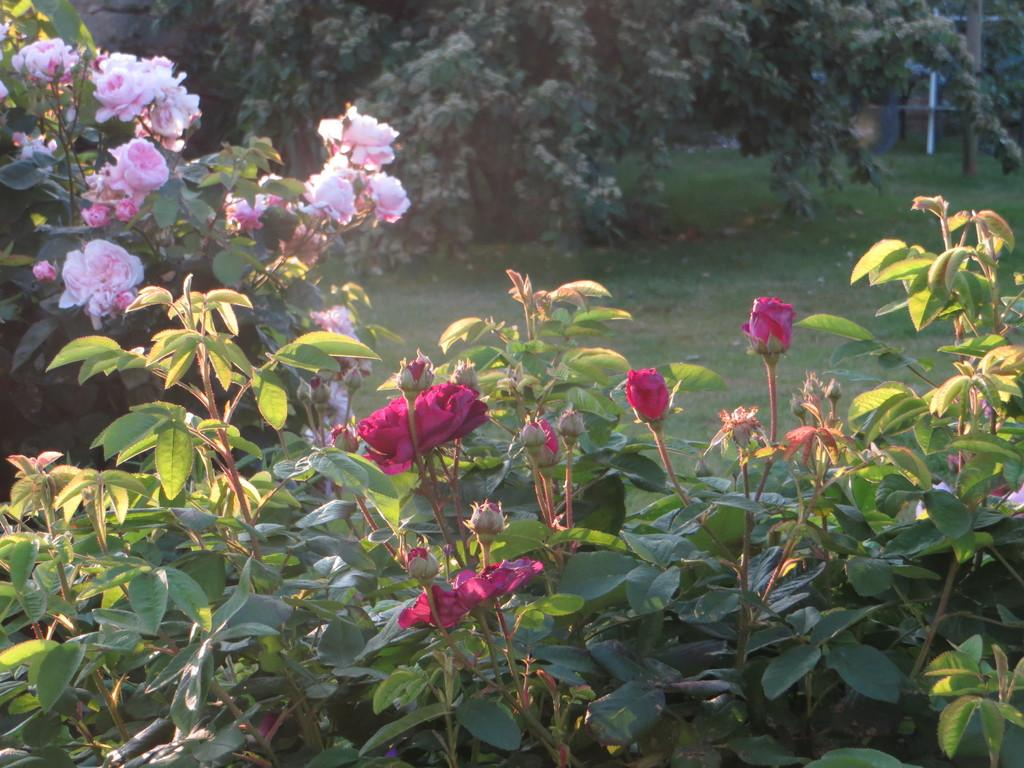What is located in the center of the image? There are trees, plants, grass, and flowers in the center of the image. What type of vegetation can be seen in the center of the image? There are plants and grass in the center of the image. What is unique about the flowers in the center of the image? The flowers in the center of the image are in different colors. Can you describe the fog in the image? There is no fog present in the image. What type of form is the railway taking in the image? There is no railway present in the image. 